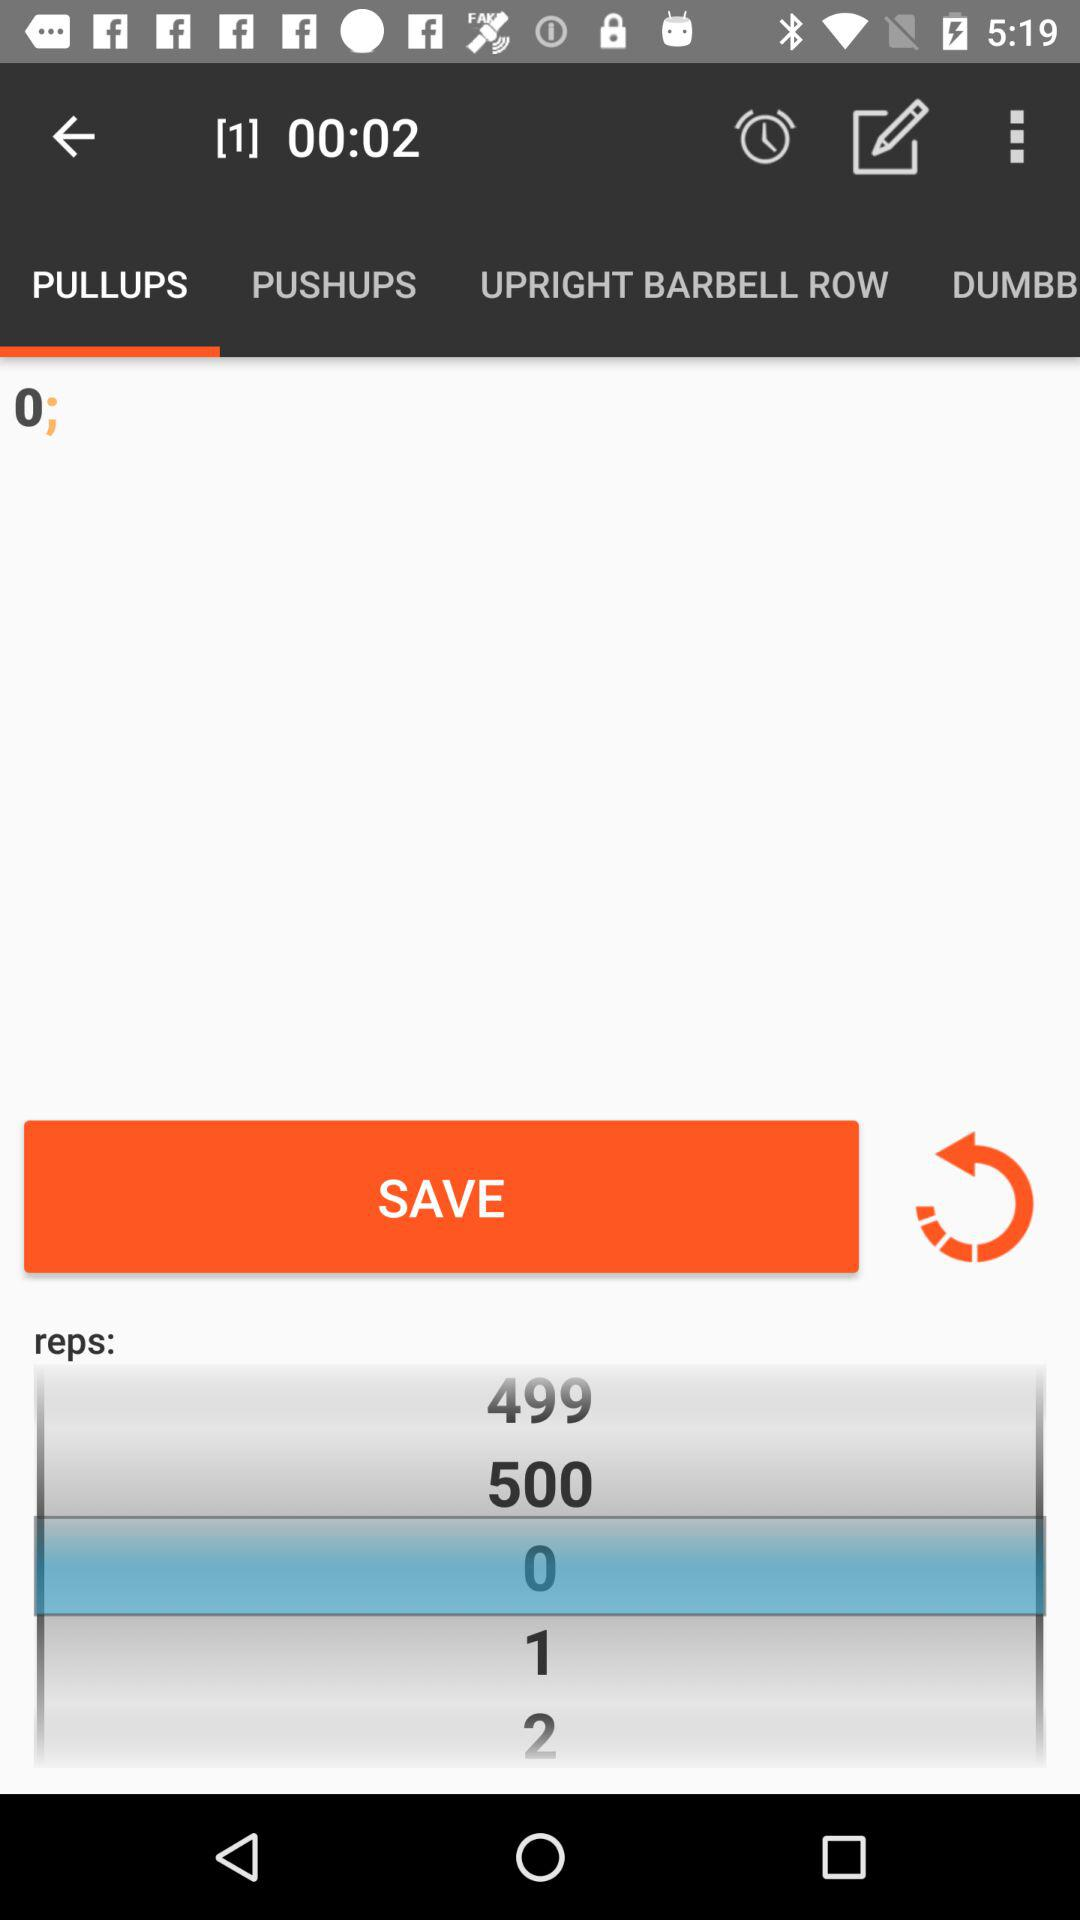How many seconds are there? There are 2 seconds. 